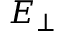Convert formula to latex. <formula><loc_0><loc_0><loc_500><loc_500>{ E } _ { \perp }</formula> 